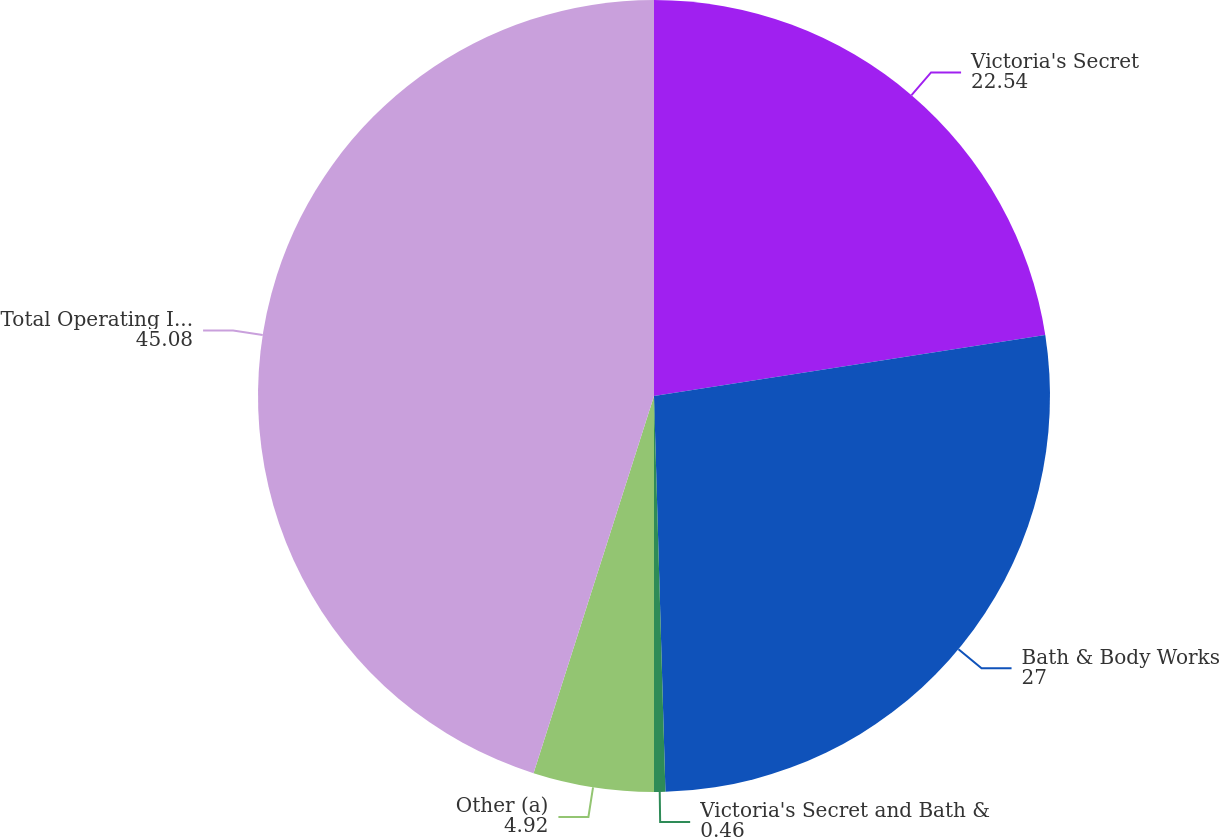<chart> <loc_0><loc_0><loc_500><loc_500><pie_chart><fcel>Victoria's Secret<fcel>Bath & Body Works<fcel>Victoria's Secret and Bath &<fcel>Other (a)<fcel>Total Operating Income<nl><fcel>22.54%<fcel>27.0%<fcel>0.46%<fcel>4.92%<fcel>45.08%<nl></chart> 